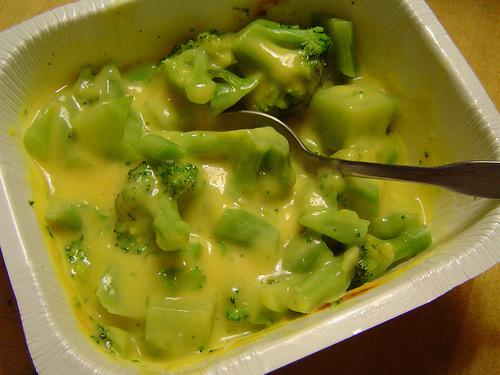How was this dish prepared? Please explain your reasoning. microwave. This is a type of container that is used in one 